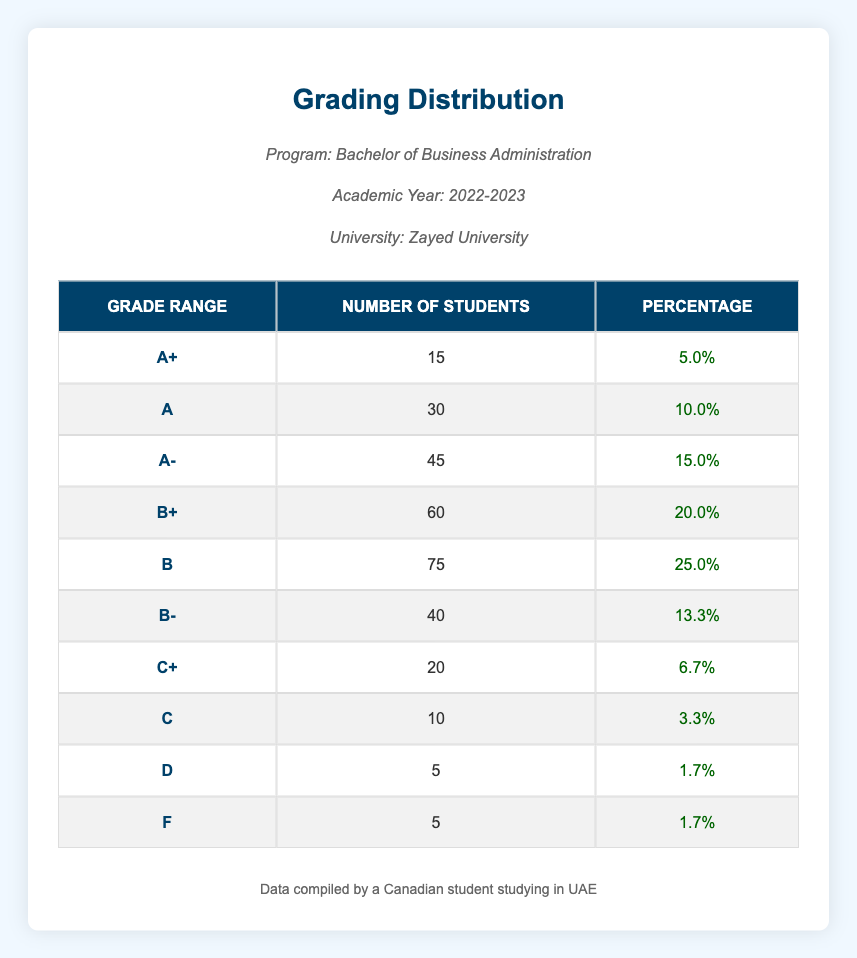What is the percentage of students who received an A grade? From the table, the percentage of students who received an A grade is clearly listed as 10.0%.
Answer: 10.0% How many students received a grade of B or higher? To find this, we need to sum the number of students in the grades B+, A-, A, and A+. The counts are 60 (B+) + 75 (B) + 45 (A-) + 30 (A) + 15 (A+) = 225 students.
Answer: 225 What is the total number of students who received a grade lower than C? The grades lower than C are D and F. The number of students receiving these grades is 5 (D) + 5 (F) = 10 students.
Answer: 10 Is it true that more students received a B than any other grade? To verify this, we compare the number of students who received grades B (75) with other grades. The next highest is B+ (60), making B the highest. Thus, it is true.
Answer: Yes What is the average percentage for grades B and B-? The percentages for grades B and B- are 25.0% for B and 13.3% for B-. The average percentage is calculated as (25.0 + 13.3) / 2 = 19.15%.
Answer: 19.15% How many grades fall between B- and C? The grades between B- and C include B, B+, and A- with students counting 75 (B) + 60 (B+) + 40 (B-) = 175 students.
Answer: 175 What is the grade with the lowest percentage of students? From the table, the grades D and F both have an equal lowest percentage of 1.7%, making it clear.
Answer: D and F Are there more students who received an A- than those who received a D? The number of students who received an A- is 45, while those who received a D is 5. Since 45 is greater than 5, the statement is true.
Answer: Yes 